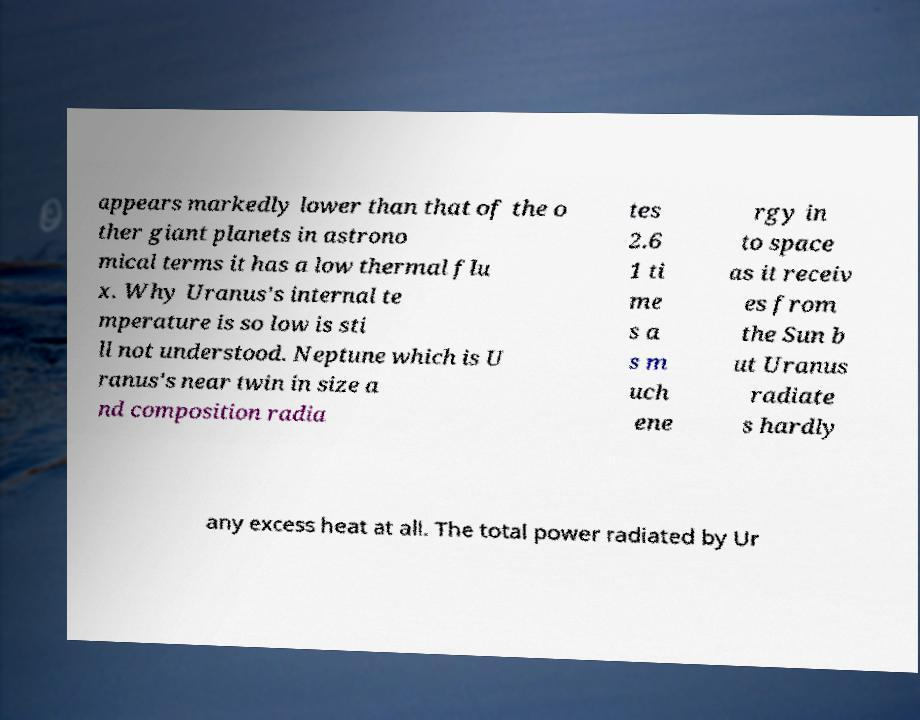I need the written content from this picture converted into text. Can you do that? appears markedly lower than that of the o ther giant planets in astrono mical terms it has a low thermal flu x. Why Uranus's internal te mperature is so low is sti ll not understood. Neptune which is U ranus's near twin in size a nd composition radia tes 2.6 1 ti me s a s m uch ene rgy in to space as it receiv es from the Sun b ut Uranus radiate s hardly any excess heat at all. The total power radiated by Ur 